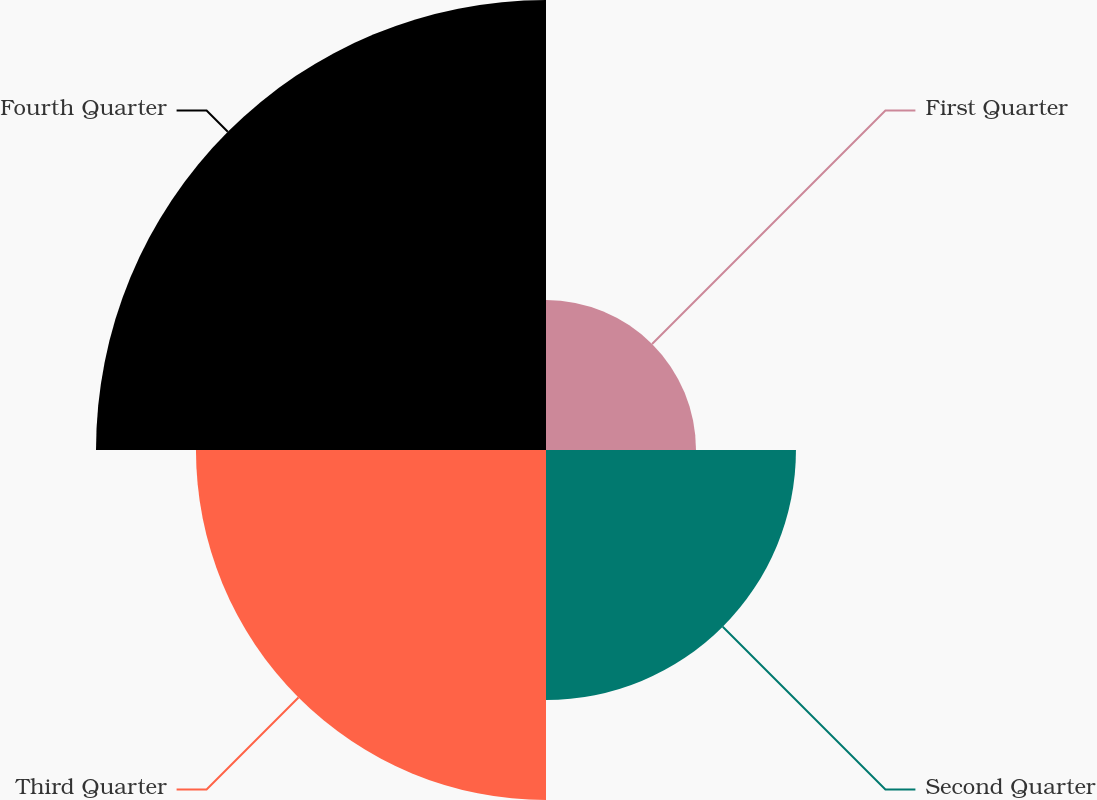Convert chart to OTSL. <chart><loc_0><loc_0><loc_500><loc_500><pie_chart><fcel>First Quarter<fcel>Second Quarter<fcel>Third Quarter<fcel>Fourth Quarter<nl><fcel>12.5%<fcel>20.83%<fcel>29.17%<fcel>37.5%<nl></chart> 